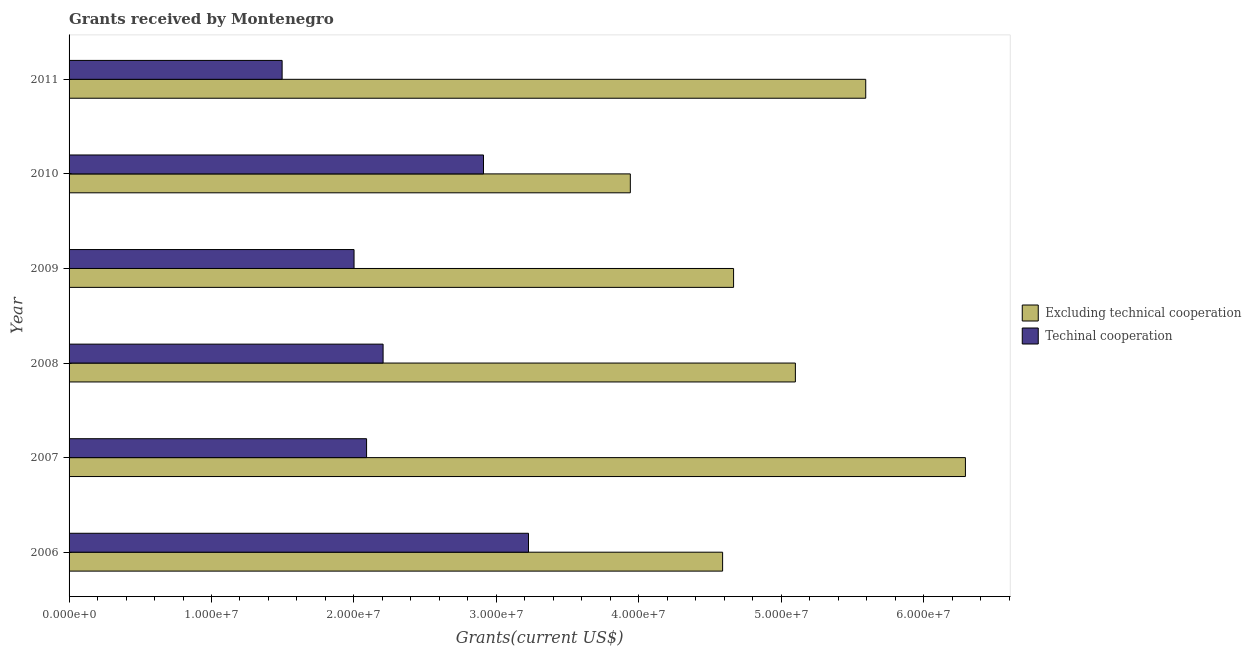How many different coloured bars are there?
Provide a succinct answer. 2. How many groups of bars are there?
Your answer should be very brief. 6. Are the number of bars on each tick of the Y-axis equal?
Your answer should be compact. Yes. What is the label of the 3rd group of bars from the top?
Your response must be concise. 2009. What is the amount of grants received(excluding technical cooperation) in 2006?
Make the answer very short. 4.59e+07. Across all years, what is the maximum amount of grants received(excluding technical cooperation)?
Ensure brevity in your answer.  6.29e+07. Across all years, what is the minimum amount of grants received(including technical cooperation)?
Keep it short and to the point. 1.50e+07. What is the total amount of grants received(including technical cooperation) in the graph?
Your response must be concise. 1.39e+08. What is the difference between the amount of grants received(excluding technical cooperation) in 2008 and that in 2010?
Offer a terse response. 1.16e+07. What is the difference between the amount of grants received(including technical cooperation) in 2009 and the amount of grants received(excluding technical cooperation) in 2008?
Your answer should be very brief. -3.10e+07. What is the average amount of grants received(including technical cooperation) per year?
Give a very brief answer. 2.32e+07. In the year 2006, what is the difference between the amount of grants received(including technical cooperation) and amount of grants received(excluding technical cooperation)?
Provide a succinct answer. -1.36e+07. In how many years, is the amount of grants received(excluding technical cooperation) greater than 34000000 US$?
Ensure brevity in your answer.  6. What is the ratio of the amount of grants received(including technical cooperation) in 2007 to that in 2011?
Your response must be concise. 1.4. Is the difference between the amount of grants received(including technical cooperation) in 2008 and 2010 greater than the difference between the amount of grants received(excluding technical cooperation) in 2008 and 2010?
Offer a very short reply. No. What is the difference between the highest and the second highest amount of grants received(including technical cooperation)?
Offer a terse response. 3.16e+06. What is the difference between the highest and the lowest amount of grants received(excluding technical cooperation)?
Provide a succinct answer. 2.35e+07. In how many years, is the amount of grants received(excluding technical cooperation) greater than the average amount of grants received(excluding technical cooperation) taken over all years?
Your response must be concise. 3. Is the sum of the amount of grants received(excluding technical cooperation) in 2006 and 2011 greater than the maximum amount of grants received(including technical cooperation) across all years?
Ensure brevity in your answer.  Yes. What does the 2nd bar from the top in 2011 represents?
Ensure brevity in your answer.  Excluding technical cooperation. What does the 2nd bar from the bottom in 2008 represents?
Keep it short and to the point. Techinal cooperation. How many bars are there?
Your answer should be compact. 12. Are all the bars in the graph horizontal?
Keep it short and to the point. Yes. Does the graph contain grids?
Provide a short and direct response. No. How many legend labels are there?
Offer a very short reply. 2. How are the legend labels stacked?
Ensure brevity in your answer.  Vertical. What is the title of the graph?
Make the answer very short. Grants received by Montenegro. What is the label or title of the X-axis?
Your answer should be very brief. Grants(current US$). What is the Grants(current US$) in Excluding technical cooperation in 2006?
Ensure brevity in your answer.  4.59e+07. What is the Grants(current US$) in Techinal cooperation in 2006?
Provide a short and direct response. 3.23e+07. What is the Grants(current US$) of Excluding technical cooperation in 2007?
Ensure brevity in your answer.  6.29e+07. What is the Grants(current US$) in Techinal cooperation in 2007?
Provide a short and direct response. 2.09e+07. What is the Grants(current US$) of Excluding technical cooperation in 2008?
Make the answer very short. 5.10e+07. What is the Grants(current US$) in Techinal cooperation in 2008?
Ensure brevity in your answer.  2.20e+07. What is the Grants(current US$) in Excluding technical cooperation in 2009?
Offer a very short reply. 4.67e+07. What is the Grants(current US$) in Techinal cooperation in 2009?
Provide a short and direct response. 2.00e+07. What is the Grants(current US$) in Excluding technical cooperation in 2010?
Your response must be concise. 3.94e+07. What is the Grants(current US$) of Techinal cooperation in 2010?
Offer a terse response. 2.91e+07. What is the Grants(current US$) in Excluding technical cooperation in 2011?
Ensure brevity in your answer.  5.59e+07. What is the Grants(current US$) in Techinal cooperation in 2011?
Your response must be concise. 1.50e+07. Across all years, what is the maximum Grants(current US$) in Excluding technical cooperation?
Give a very brief answer. 6.29e+07. Across all years, what is the maximum Grants(current US$) of Techinal cooperation?
Offer a very short reply. 3.23e+07. Across all years, what is the minimum Grants(current US$) of Excluding technical cooperation?
Ensure brevity in your answer.  3.94e+07. Across all years, what is the minimum Grants(current US$) of Techinal cooperation?
Your answer should be compact. 1.50e+07. What is the total Grants(current US$) of Excluding technical cooperation in the graph?
Your response must be concise. 3.02e+08. What is the total Grants(current US$) in Techinal cooperation in the graph?
Provide a succinct answer. 1.39e+08. What is the difference between the Grants(current US$) in Excluding technical cooperation in 2006 and that in 2007?
Offer a terse response. -1.70e+07. What is the difference between the Grants(current US$) in Techinal cooperation in 2006 and that in 2007?
Keep it short and to the point. 1.14e+07. What is the difference between the Grants(current US$) of Excluding technical cooperation in 2006 and that in 2008?
Keep it short and to the point. -5.11e+06. What is the difference between the Grants(current US$) of Techinal cooperation in 2006 and that in 2008?
Give a very brief answer. 1.02e+07. What is the difference between the Grants(current US$) of Excluding technical cooperation in 2006 and that in 2009?
Provide a succinct answer. -7.70e+05. What is the difference between the Grants(current US$) of Techinal cooperation in 2006 and that in 2009?
Ensure brevity in your answer.  1.22e+07. What is the difference between the Grants(current US$) in Excluding technical cooperation in 2006 and that in 2010?
Keep it short and to the point. 6.48e+06. What is the difference between the Grants(current US$) of Techinal cooperation in 2006 and that in 2010?
Give a very brief answer. 3.16e+06. What is the difference between the Grants(current US$) in Excluding technical cooperation in 2006 and that in 2011?
Your answer should be compact. -1.00e+07. What is the difference between the Grants(current US$) in Techinal cooperation in 2006 and that in 2011?
Provide a short and direct response. 1.73e+07. What is the difference between the Grants(current US$) of Excluding technical cooperation in 2007 and that in 2008?
Offer a very short reply. 1.19e+07. What is the difference between the Grants(current US$) of Techinal cooperation in 2007 and that in 2008?
Ensure brevity in your answer.  -1.16e+06. What is the difference between the Grants(current US$) in Excluding technical cooperation in 2007 and that in 2009?
Your response must be concise. 1.63e+07. What is the difference between the Grants(current US$) of Techinal cooperation in 2007 and that in 2009?
Your answer should be very brief. 8.80e+05. What is the difference between the Grants(current US$) of Excluding technical cooperation in 2007 and that in 2010?
Your answer should be compact. 2.35e+07. What is the difference between the Grants(current US$) of Techinal cooperation in 2007 and that in 2010?
Provide a succinct answer. -8.21e+06. What is the difference between the Grants(current US$) in Techinal cooperation in 2007 and that in 2011?
Offer a very short reply. 5.93e+06. What is the difference between the Grants(current US$) in Excluding technical cooperation in 2008 and that in 2009?
Provide a succinct answer. 4.34e+06. What is the difference between the Grants(current US$) of Techinal cooperation in 2008 and that in 2009?
Provide a succinct answer. 2.04e+06. What is the difference between the Grants(current US$) of Excluding technical cooperation in 2008 and that in 2010?
Make the answer very short. 1.16e+07. What is the difference between the Grants(current US$) in Techinal cooperation in 2008 and that in 2010?
Ensure brevity in your answer.  -7.05e+06. What is the difference between the Grants(current US$) of Excluding technical cooperation in 2008 and that in 2011?
Make the answer very short. -4.94e+06. What is the difference between the Grants(current US$) in Techinal cooperation in 2008 and that in 2011?
Provide a succinct answer. 7.09e+06. What is the difference between the Grants(current US$) of Excluding technical cooperation in 2009 and that in 2010?
Your response must be concise. 7.25e+06. What is the difference between the Grants(current US$) in Techinal cooperation in 2009 and that in 2010?
Your answer should be very brief. -9.09e+06. What is the difference between the Grants(current US$) of Excluding technical cooperation in 2009 and that in 2011?
Keep it short and to the point. -9.28e+06. What is the difference between the Grants(current US$) in Techinal cooperation in 2009 and that in 2011?
Offer a very short reply. 5.05e+06. What is the difference between the Grants(current US$) of Excluding technical cooperation in 2010 and that in 2011?
Provide a short and direct response. -1.65e+07. What is the difference between the Grants(current US$) of Techinal cooperation in 2010 and that in 2011?
Offer a terse response. 1.41e+07. What is the difference between the Grants(current US$) of Excluding technical cooperation in 2006 and the Grants(current US$) of Techinal cooperation in 2007?
Make the answer very short. 2.50e+07. What is the difference between the Grants(current US$) of Excluding technical cooperation in 2006 and the Grants(current US$) of Techinal cooperation in 2008?
Give a very brief answer. 2.38e+07. What is the difference between the Grants(current US$) of Excluding technical cooperation in 2006 and the Grants(current US$) of Techinal cooperation in 2009?
Give a very brief answer. 2.59e+07. What is the difference between the Grants(current US$) in Excluding technical cooperation in 2006 and the Grants(current US$) in Techinal cooperation in 2010?
Offer a terse response. 1.68e+07. What is the difference between the Grants(current US$) in Excluding technical cooperation in 2006 and the Grants(current US$) in Techinal cooperation in 2011?
Provide a short and direct response. 3.09e+07. What is the difference between the Grants(current US$) of Excluding technical cooperation in 2007 and the Grants(current US$) of Techinal cooperation in 2008?
Offer a very short reply. 4.09e+07. What is the difference between the Grants(current US$) of Excluding technical cooperation in 2007 and the Grants(current US$) of Techinal cooperation in 2009?
Your answer should be very brief. 4.29e+07. What is the difference between the Grants(current US$) in Excluding technical cooperation in 2007 and the Grants(current US$) in Techinal cooperation in 2010?
Ensure brevity in your answer.  3.38e+07. What is the difference between the Grants(current US$) of Excluding technical cooperation in 2007 and the Grants(current US$) of Techinal cooperation in 2011?
Your answer should be compact. 4.80e+07. What is the difference between the Grants(current US$) of Excluding technical cooperation in 2008 and the Grants(current US$) of Techinal cooperation in 2009?
Provide a succinct answer. 3.10e+07. What is the difference between the Grants(current US$) in Excluding technical cooperation in 2008 and the Grants(current US$) in Techinal cooperation in 2010?
Your answer should be compact. 2.19e+07. What is the difference between the Grants(current US$) in Excluding technical cooperation in 2008 and the Grants(current US$) in Techinal cooperation in 2011?
Ensure brevity in your answer.  3.60e+07. What is the difference between the Grants(current US$) of Excluding technical cooperation in 2009 and the Grants(current US$) of Techinal cooperation in 2010?
Offer a very short reply. 1.76e+07. What is the difference between the Grants(current US$) in Excluding technical cooperation in 2009 and the Grants(current US$) in Techinal cooperation in 2011?
Ensure brevity in your answer.  3.17e+07. What is the difference between the Grants(current US$) of Excluding technical cooperation in 2010 and the Grants(current US$) of Techinal cooperation in 2011?
Your answer should be compact. 2.44e+07. What is the average Grants(current US$) of Excluding technical cooperation per year?
Provide a succinct answer. 5.03e+07. What is the average Grants(current US$) of Techinal cooperation per year?
Your answer should be very brief. 2.32e+07. In the year 2006, what is the difference between the Grants(current US$) of Excluding technical cooperation and Grants(current US$) of Techinal cooperation?
Your answer should be very brief. 1.36e+07. In the year 2007, what is the difference between the Grants(current US$) of Excluding technical cooperation and Grants(current US$) of Techinal cooperation?
Keep it short and to the point. 4.20e+07. In the year 2008, what is the difference between the Grants(current US$) of Excluding technical cooperation and Grants(current US$) of Techinal cooperation?
Make the answer very short. 2.90e+07. In the year 2009, what is the difference between the Grants(current US$) in Excluding technical cooperation and Grants(current US$) in Techinal cooperation?
Ensure brevity in your answer.  2.66e+07. In the year 2010, what is the difference between the Grants(current US$) in Excluding technical cooperation and Grants(current US$) in Techinal cooperation?
Your answer should be very brief. 1.03e+07. In the year 2011, what is the difference between the Grants(current US$) in Excluding technical cooperation and Grants(current US$) in Techinal cooperation?
Offer a very short reply. 4.10e+07. What is the ratio of the Grants(current US$) in Excluding technical cooperation in 2006 to that in 2007?
Give a very brief answer. 0.73. What is the ratio of the Grants(current US$) of Techinal cooperation in 2006 to that in 2007?
Your response must be concise. 1.54. What is the ratio of the Grants(current US$) of Excluding technical cooperation in 2006 to that in 2008?
Your response must be concise. 0.9. What is the ratio of the Grants(current US$) of Techinal cooperation in 2006 to that in 2008?
Ensure brevity in your answer.  1.46. What is the ratio of the Grants(current US$) of Excluding technical cooperation in 2006 to that in 2009?
Offer a very short reply. 0.98. What is the ratio of the Grants(current US$) of Techinal cooperation in 2006 to that in 2009?
Offer a terse response. 1.61. What is the ratio of the Grants(current US$) in Excluding technical cooperation in 2006 to that in 2010?
Your response must be concise. 1.16. What is the ratio of the Grants(current US$) of Techinal cooperation in 2006 to that in 2010?
Ensure brevity in your answer.  1.11. What is the ratio of the Grants(current US$) of Excluding technical cooperation in 2006 to that in 2011?
Provide a succinct answer. 0.82. What is the ratio of the Grants(current US$) of Techinal cooperation in 2006 to that in 2011?
Your response must be concise. 2.16. What is the ratio of the Grants(current US$) of Excluding technical cooperation in 2007 to that in 2008?
Give a very brief answer. 1.23. What is the ratio of the Grants(current US$) in Excluding technical cooperation in 2007 to that in 2009?
Your answer should be very brief. 1.35. What is the ratio of the Grants(current US$) of Techinal cooperation in 2007 to that in 2009?
Keep it short and to the point. 1.04. What is the ratio of the Grants(current US$) in Excluding technical cooperation in 2007 to that in 2010?
Make the answer very short. 1.6. What is the ratio of the Grants(current US$) of Techinal cooperation in 2007 to that in 2010?
Make the answer very short. 0.72. What is the ratio of the Grants(current US$) of Excluding technical cooperation in 2007 to that in 2011?
Your answer should be compact. 1.13. What is the ratio of the Grants(current US$) in Techinal cooperation in 2007 to that in 2011?
Your answer should be compact. 1.4. What is the ratio of the Grants(current US$) of Excluding technical cooperation in 2008 to that in 2009?
Ensure brevity in your answer.  1.09. What is the ratio of the Grants(current US$) in Techinal cooperation in 2008 to that in 2009?
Provide a short and direct response. 1.1. What is the ratio of the Grants(current US$) in Excluding technical cooperation in 2008 to that in 2010?
Offer a very short reply. 1.29. What is the ratio of the Grants(current US$) of Techinal cooperation in 2008 to that in 2010?
Provide a short and direct response. 0.76. What is the ratio of the Grants(current US$) of Excluding technical cooperation in 2008 to that in 2011?
Ensure brevity in your answer.  0.91. What is the ratio of the Grants(current US$) in Techinal cooperation in 2008 to that in 2011?
Provide a short and direct response. 1.47. What is the ratio of the Grants(current US$) of Excluding technical cooperation in 2009 to that in 2010?
Offer a terse response. 1.18. What is the ratio of the Grants(current US$) in Techinal cooperation in 2009 to that in 2010?
Offer a terse response. 0.69. What is the ratio of the Grants(current US$) of Excluding technical cooperation in 2009 to that in 2011?
Keep it short and to the point. 0.83. What is the ratio of the Grants(current US$) in Techinal cooperation in 2009 to that in 2011?
Offer a terse response. 1.34. What is the ratio of the Grants(current US$) in Excluding technical cooperation in 2010 to that in 2011?
Keep it short and to the point. 0.7. What is the ratio of the Grants(current US$) in Techinal cooperation in 2010 to that in 2011?
Give a very brief answer. 1.95. What is the difference between the highest and the second highest Grants(current US$) in Excluding technical cooperation?
Provide a succinct answer. 7.00e+06. What is the difference between the highest and the second highest Grants(current US$) in Techinal cooperation?
Your answer should be compact. 3.16e+06. What is the difference between the highest and the lowest Grants(current US$) in Excluding technical cooperation?
Your answer should be compact. 2.35e+07. What is the difference between the highest and the lowest Grants(current US$) in Techinal cooperation?
Give a very brief answer. 1.73e+07. 